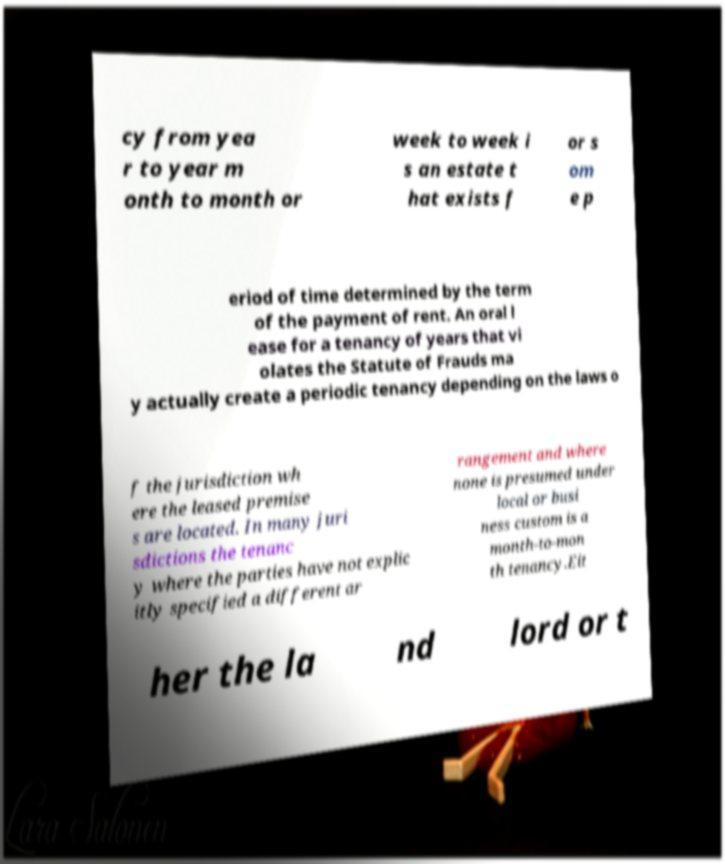For documentation purposes, I need the text within this image transcribed. Could you provide that? cy from yea r to year m onth to month or week to week i s an estate t hat exists f or s om e p eriod of time determined by the term of the payment of rent. An oral l ease for a tenancy of years that vi olates the Statute of Frauds ma y actually create a periodic tenancy depending on the laws o f the jurisdiction wh ere the leased premise s are located. In many juri sdictions the tenanc y where the parties have not explic itly specified a different ar rangement and where none is presumed under local or busi ness custom is a month-to-mon th tenancy.Eit her the la nd lord or t 